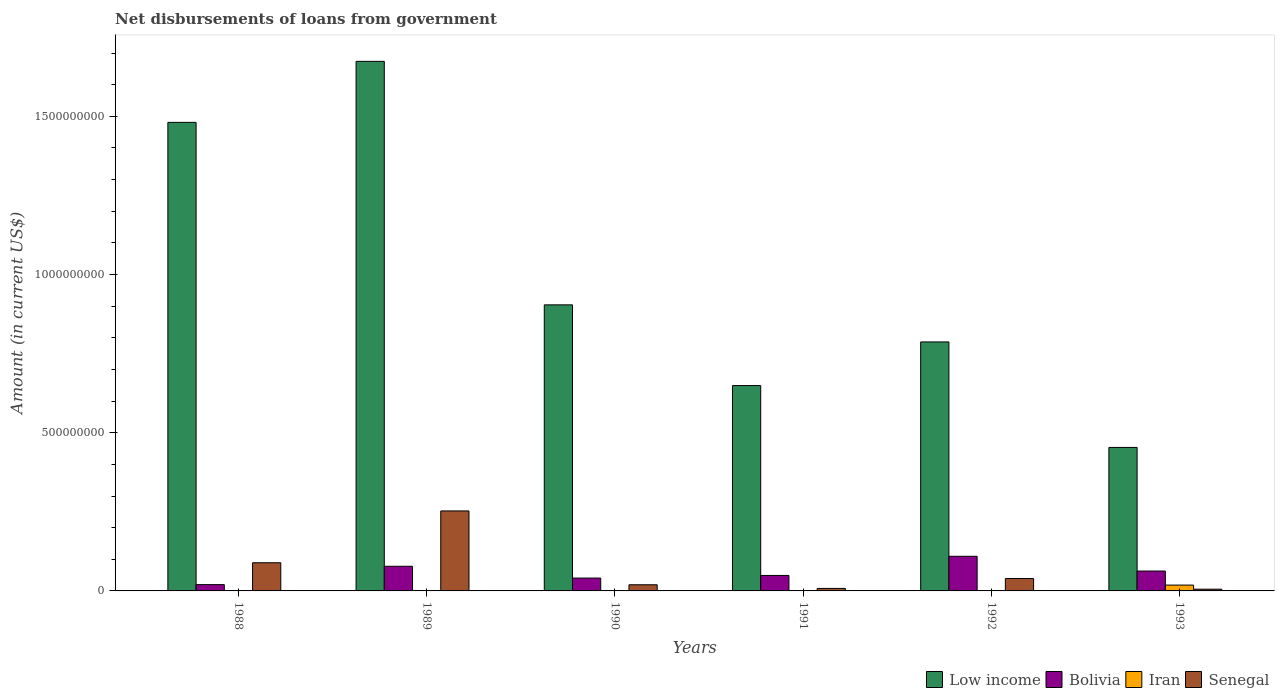How many different coloured bars are there?
Your answer should be compact. 4. How many bars are there on the 1st tick from the left?
Your answer should be compact. 3. How many bars are there on the 4th tick from the right?
Offer a very short reply. 3. What is the label of the 6th group of bars from the left?
Offer a terse response. 1993. In how many cases, is the number of bars for a given year not equal to the number of legend labels?
Make the answer very short. 5. What is the amount of loan disbursed from government in Bolivia in 1989?
Your response must be concise. 7.79e+07. Across all years, what is the maximum amount of loan disbursed from government in Low income?
Give a very brief answer. 1.67e+09. Across all years, what is the minimum amount of loan disbursed from government in Iran?
Offer a terse response. 0. What is the total amount of loan disbursed from government in Iran in the graph?
Your response must be concise. 1.85e+07. What is the difference between the amount of loan disbursed from government in Bolivia in 1991 and that in 1993?
Make the answer very short. -1.39e+07. What is the difference between the amount of loan disbursed from government in Low income in 1992 and the amount of loan disbursed from government in Bolivia in 1989?
Your response must be concise. 7.09e+08. What is the average amount of loan disbursed from government in Iran per year?
Ensure brevity in your answer.  3.08e+06. In the year 1989, what is the difference between the amount of loan disbursed from government in Bolivia and amount of loan disbursed from government in Low income?
Provide a short and direct response. -1.60e+09. In how many years, is the amount of loan disbursed from government in Bolivia greater than 100000000 US$?
Provide a succinct answer. 1. What is the ratio of the amount of loan disbursed from government in Low income in 1989 to that in 1993?
Your answer should be compact. 3.69. Is the difference between the amount of loan disbursed from government in Bolivia in 1989 and 1991 greater than the difference between the amount of loan disbursed from government in Low income in 1989 and 1991?
Keep it short and to the point. No. What is the difference between the highest and the second highest amount of loan disbursed from government in Senegal?
Provide a short and direct response. 1.64e+08. What is the difference between the highest and the lowest amount of loan disbursed from government in Low income?
Give a very brief answer. 1.22e+09. In how many years, is the amount of loan disbursed from government in Senegal greater than the average amount of loan disbursed from government in Senegal taken over all years?
Ensure brevity in your answer.  2. Is the sum of the amount of loan disbursed from government in Bolivia in 1992 and 1993 greater than the maximum amount of loan disbursed from government in Low income across all years?
Your answer should be very brief. No. Is it the case that in every year, the sum of the amount of loan disbursed from government in Bolivia and amount of loan disbursed from government in Low income is greater than the amount of loan disbursed from government in Senegal?
Keep it short and to the point. Yes. How many bars are there?
Ensure brevity in your answer.  19. Does the graph contain grids?
Keep it short and to the point. No. Where does the legend appear in the graph?
Offer a very short reply. Bottom right. How many legend labels are there?
Keep it short and to the point. 4. How are the legend labels stacked?
Keep it short and to the point. Horizontal. What is the title of the graph?
Your answer should be very brief. Net disbursements of loans from government. Does "China" appear as one of the legend labels in the graph?
Make the answer very short. No. What is the label or title of the X-axis?
Make the answer very short. Years. What is the Amount (in current US$) of Low income in 1988?
Give a very brief answer. 1.48e+09. What is the Amount (in current US$) of Bolivia in 1988?
Offer a very short reply. 1.99e+07. What is the Amount (in current US$) in Iran in 1988?
Make the answer very short. 0. What is the Amount (in current US$) of Senegal in 1988?
Provide a short and direct response. 8.91e+07. What is the Amount (in current US$) of Low income in 1989?
Provide a short and direct response. 1.67e+09. What is the Amount (in current US$) in Bolivia in 1989?
Ensure brevity in your answer.  7.79e+07. What is the Amount (in current US$) of Iran in 1989?
Keep it short and to the point. 0. What is the Amount (in current US$) in Senegal in 1989?
Your answer should be compact. 2.53e+08. What is the Amount (in current US$) of Low income in 1990?
Make the answer very short. 9.04e+08. What is the Amount (in current US$) of Bolivia in 1990?
Ensure brevity in your answer.  4.06e+07. What is the Amount (in current US$) of Senegal in 1990?
Your response must be concise. 1.95e+07. What is the Amount (in current US$) of Low income in 1991?
Offer a terse response. 6.49e+08. What is the Amount (in current US$) in Bolivia in 1991?
Your answer should be compact. 4.89e+07. What is the Amount (in current US$) in Iran in 1991?
Ensure brevity in your answer.  0. What is the Amount (in current US$) in Senegal in 1991?
Provide a short and direct response. 7.91e+06. What is the Amount (in current US$) of Low income in 1992?
Your answer should be very brief. 7.87e+08. What is the Amount (in current US$) in Bolivia in 1992?
Your answer should be compact. 1.09e+08. What is the Amount (in current US$) of Iran in 1992?
Make the answer very short. 0. What is the Amount (in current US$) in Senegal in 1992?
Make the answer very short. 3.92e+07. What is the Amount (in current US$) in Low income in 1993?
Your response must be concise. 4.54e+08. What is the Amount (in current US$) of Bolivia in 1993?
Provide a short and direct response. 6.29e+07. What is the Amount (in current US$) in Iran in 1993?
Offer a very short reply. 1.85e+07. What is the Amount (in current US$) of Senegal in 1993?
Make the answer very short. 5.51e+06. Across all years, what is the maximum Amount (in current US$) in Low income?
Provide a succinct answer. 1.67e+09. Across all years, what is the maximum Amount (in current US$) in Bolivia?
Your answer should be very brief. 1.09e+08. Across all years, what is the maximum Amount (in current US$) of Iran?
Offer a terse response. 1.85e+07. Across all years, what is the maximum Amount (in current US$) of Senegal?
Your answer should be compact. 2.53e+08. Across all years, what is the minimum Amount (in current US$) in Low income?
Give a very brief answer. 4.54e+08. Across all years, what is the minimum Amount (in current US$) in Bolivia?
Ensure brevity in your answer.  1.99e+07. Across all years, what is the minimum Amount (in current US$) of Senegal?
Your response must be concise. 5.51e+06. What is the total Amount (in current US$) in Low income in the graph?
Offer a very short reply. 5.95e+09. What is the total Amount (in current US$) in Bolivia in the graph?
Your response must be concise. 3.60e+08. What is the total Amount (in current US$) in Iran in the graph?
Make the answer very short. 1.85e+07. What is the total Amount (in current US$) of Senegal in the graph?
Offer a terse response. 4.14e+08. What is the difference between the Amount (in current US$) of Low income in 1988 and that in 1989?
Give a very brief answer. -1.93e+08. What is the difference between the Amount (in current US$) in Bolivia in 1988 and that in 1989?
Give a very brief answer. -5.79e+07. What is the difference between the Amount (in current US$) of Senegal in 1988 and that in 1989?
Keep it short and to the point. -1.64e+08. What is the difference between the Amount (in current US$) in Low income in 1988 and that in 1990?
Your answer should be compact. 5.77e+08. What is the difference between the Amount (in current US$) of Bolivia in 1988 and that in 1990?
Your answer should be very brief. -2.07e+07. What is the difference between the Amount (in current US$) in Senegal in 1988 and that in 1990?
Provide a short and direct response. 6.96e+07. What is the difference between the Amount (in current US$) in Low income in 1988 and that in 1991?
Make the answer very short. 8.32e+08. What is the difference between the Amount (in current US$) of Bolivia in 1988 and that in 1991?
Your answer should be very brief. -2.90e+07. What is the difference between the Amount (in current US$) of Senegal in 1988 and that in 1991?
Your answer should be very brief. 8.12e+07. What is the difference between the Amount (in current US$) of Low income in 1988 and that in 1992?
Your answer should be compact. 6.94e+08. What is the difference between the Amount (in current US$) in Bolivia in 1988 and that in 1992?
Offer a very short reply. -8.95e+07. What is the difference between the Amount (in current US$) of Senegal in 1988 and that in 1992?
Make the answer very short. 4.99e+07. What is the difference between the Amount (in current US$) in Low income in 1988 and that in 1993?
Offer a terse response. 1.03e+09. What is the difference between the Amount (in current US$) of Bolivia in 1988 and that in 1993?
Provide a succinct answer. -4.29e+07. What is the difference between the Amount (in current US$) of Senegal in 1988 and that in 1993?
Give a very brief answer. 8.36e+07. What is the difference between the Amount (in current US$) in Low income in 1989 and that in 1990?
Offer a terse response. 7.70e+08. What is the difference between the Amount (in current US$) of Bolivia in 1989 and that in 1990?
Your answer should be very brief. 3.73e+07. What is the difference between the Amount (in current US$) of Senegal in 1989 and that in 1990?
Make the answer very short. 2.33e+08. What is the difference between the Amount (in current US$) of Low income in 1989 and that in 1991?
Keep it short and to the point. 1.02e+09. What is the difference between the Amount (in current US$) in Bolivia in 1989 and that in 1991?
Your answer should be very brief. 2.89e+07. What is the difference between the Amount (in current US$) of Senegal in 1989 and that in 1991?
Your answer should be compact. 2.45e+08. What is the difference between the Amount (in current US$) of Low income in 1989 and that in 1992?
Make the answer very short. 8.87e+08. What is the difference between the Amount (in current US$) in Bolivia in 1989 and that in 1992?
Your response must be concise. -3.16e+07. What is the difference between the Amount (in current US$) of Senegal in 1989 and that in 1992?
Offer a very short reply. 2.14e+08. What is the difference between the Amount (in current US$) in Low income in 1989 and that in 1993?
Offer a terse response. 1.22e+09. What is the difference between the Amount (in current US$) of Bolivia in 1989 and that in 1993?
Ensure brevity in your answer.  1.50e+07. What is the difference between the Amount (in current US$) in Senegal in 1989 and that in 1993?
Offer a terse response. 2.47e+08. What is the difference between the Amount (in current US$) in Low income in 1990 and that in 1991?
Your response must be concise. 2.55e+08. What is the difference between the Amount (in current US$) in Bolivia in 1990 and that in 1991?
Make the answer very short. -8.34e+06. What is the difference between the Amount (in current US$) of Senegal in 1990 and that in 1991?
Your answer should be compact. 1.15e+07. What is the difference between the Amount (in current US$) in Low income in 1990 and that in 1992?
Ensure brevity in your answer.  1.17e+08. What is the difference between the Amount (in current US$) of Bolivia in 1990 and that in 1992?
Give a very brief answer. -6.89e+07. What is the difference between the Amount (in current US$) in Senegal in 1990 and that in 1992?
Keep it short and to the point. -1.97e+07. What is the difference between the Amount (in current US$) of Low income in 1990 and that in 1993?
Your answer should be very brief. 4.51e+08. What is the difference between the Amount (in current US$) in Bolivia in 1990 and that in 1993?
Keep it short and to the point. -2.23e+07. What is the difference between the Amount (in current US$) of Senegal in 1990 and that in 1993?
Your answer should be compact. 1.39e+07. What is the difference between the Amount (in current US$) in Low income in 1991 and that in 1992?
Make the answer very short. -1.38e+08. What is the difference between the Amount (in current US$) in Bolivia in 1991 and that in 1992?
Offer a very short reply. -6.05e+07. What is the difference between the Amount (in current US$) of Senegal in 1991 and that in 1992?
Provide a short and direct response. -3.13e+07. What is the difference between the Amount (in current US$) in Low income in 1991 and that in 1993?
Keep it short and to the point. 1.96e+08. What is the difference between the Amount (in current US$) of Bolivia in 1991 and that in 1993?
Your response must be concise. -1.39e+07. What is the difference between the Amount (in current US$) in Senegal in 1991 and that in 1993?
Ensure brevity in your answer.  2.40e+06. What is the difference between the Amount (in current US$) in Low income in 1992 and that in 1993?
Ensure brevity in your answer.  3.33e+08. What is the difference between the Amount (in current US$) of Bolivia in 1992 and that in 1993?
Your response must be concise. 4.66e+07. What is the difference between the Amount (in current US$) of Senegal in 1992 and that in 1993?
Provide a succinct answer. 3.37e+07. What is the difference between the Amount (in current US$) of Low income in 1988 and the Amount (in current US$) of Bolivia in 1989?
Your answer should be very brief. 1.40e+09. What is the difference between the Amount (in current US$) in Low income in 1988 and the Amount (in current US$) in Senegal in 1989?
Ensure brevity in your answer.  1.23e+09. What is the difference between the Amount (in current US$) in Bolivia in 1988 and the Amount (in current US$) in Senegal in 1989?
Make the answer very short. -2.33e+08. What is the difference between the Amount (in current US$) in Low income in 1988 and the Amount (in current US$) in Bolivia in 1990?
Offer a very short reply. 1.44e+09. What is the difference between the Amount (in current US$) in Low income in 1988 and the Amount (in current US$) in Senegal in 1990?
Provide a short and direct response. 1.46e+09. What is the difference between the Amount (in current US$) of Bolivia in 1988 and the Amount (in current US$) of Senegal in 1990?
Your answer should be very brief. 4.83e+05. What is the difference between the Amount (in current US$) in Low income in 1988 and the Amount (in current US$) in Bolivia in 1991?
Your response must be concise. 1.43e+09. What is the difference between the Amount (in current US$) in Low income in 1988 and the Amount (in current US$) in Senegal in 1991?
Ensure brevity in your answer.  1.47e+09. What is the difference between the Amount (in current US$) in Bolivia in 1988 and the Amount (in current US$) in Senegal in 1991?
Offer a very short reply. 1.20e+07. What is the difference between the Amount (in current US$) in Low income in 1988 and the Amount (in current US$) in Bolivia in 1992?
Your answer should be compact. 1.37e+09. What is the difference between the Amount (in current US$) of Low income in 1988 and the Amount (in current US$) of Senegal in 1992?
Keep it short and to the point. 1.44e+09. What is the difference between the Amount (in current US$) in Bolivia in 1988 and the Amount (in current US$) in Senegal in 1992?
Ensure brevity in your answer.  -1.92e+07. What is the difference between the Amount (in current US$) in Low income in 1988 and the Amount (in current US$) in Bolivia in 1993?
Make the answer very short. 1.42e+09. What is the difference between the Amount (in current US$) in Low income in 1988 and the Amount (in current US$) in Iran in 1993?
Your answer should be compact. 1.46e+09. What is the difference between the Amount (in current US$) in Low income in 1988 and the Amount (in current US$) in Senegal in 1993?
Make the answer very short. 1.48e+09. What is the difference between the Amount (in current US$) in Bolivia in 1988 and the Amount (in current US$) in Iran in 1993?
Your response must be concise. 1.48e+06. What is the difference between the Amount (in current US$) in Bolivia in 1988 and the Amount (in current US$) in Senegal in 1993?
Offer a very short reply. 1.44e+07. What is the difference between the Amount (in current US$) in Low income in 1989 and the Amount (in current US$) in Bolivia in 1990?
Provide a short and direct response. 1.63e+09. What is the difference between the Amount (in current US$) of Low income in 1989 and the Amount (in current US$) of Senegal in 1990?
Your answer should be compact. 1.65e+09. What is the difference between the Amount (in current US$) of Bolivia in 1989 and the Amount (in current US$) of Senegal in 1990?
Offer a terse response. 5.84e+07. What is the difference between the Amount (in current US$) in Low income in 1989 and the Amount (in current US$) in Bolivia in 1991?
Your answer should be very brief. 1.62e+09. What is the difference between the Amount (in current US$) of Low income in 1989 and the Amount (in current US$) of Senegal in 1991?
Your answer should be compact. 1.67e+09. What is the difference between the Amount (in current US$) of Bolivia in 1989 and the Amount (in current US$) of Senegal in 1991?
Provide a succinct answer. 7.00e+07. What is the difference between the Amount (in current US$) in Low income in 1989 and the Amount (in current US$) in Bolivia in 1992?
Make the answer very short. 1.56e+09. What is the difference between the Amount (in current US$) of Low income in 1989 and the Amount (in current US$) of Senegal in 1992?
Keep it short and to the point. 1.63e+09. What is the difference between the Amount (in current US$) of Bolivia in 1989 and the Amount (in current US$) of Senegal in 1992?
Offer a very short reply. 3.87e+07. What is the difference between the Amount (in current US$) in Low income in 1989 and the Amount (in current US$) in Bolivia in 1993?
Your answer should be very brief. 1.61e+09. What is the difference between the Amount (in current US$) of Low income in 1989 and the Amount (in current US$) of Iran in 1993?
Offer a very short reply. 1.66e+09. What is the difference between the Amount (in current US$) in Low income in 1989 and the Amount (in current US$) in Senegal in 1993?
Offer a terse response. 1.67e+09. What is the difference between the Amount (in current US$) of Bolivia in 1989 and the Amount (in current US$) of Iran in 1993?
Ensure brevity in your answer.  5.94e+07. What is the difference between the Amount (in current US$) in Bolivia in 1989 and the Amount (in current US$) in Senegal in 1993?
Offer a very short reply. 7.24e+07. What is the difference between the Amount (in current US$) of Low income in 1990 and the Amount (in current US$) of Bolivia in 1991?
Offer a very short reply. 8.55e+08. What is the difference between the Amount (in current US$) of Low income in 1990 and the Amount (in current US$) of Senegal in 1991?
Keep it short and to the point. 8.96e+08. What is the difference between the Amount (in current US$) of Bolivia in 1990 and the Amount (in current US$) of Senegal in 1991?
Your answer should be very brief. 3.27e+07. What is the difference between the Amount (in current US$) of Low income in 1990 and the Amount (in current US$) of Bolivia in 1992?
Provide a short and direct response. 7.95e+08. What is the difference between the Amount (in current US$) in Low income in 1990 and the Amount (in current US$) in Senegal in 1992?
Provide a succinct answer. 8.65e+08. What is the difference between the Amount (in current US$) in Bolivia in 1990 and the Amount (in current US$) in Senegal in 1992?
Ensure brevity in your answer.  1.43e+06. What is the difference between the Amount (in current US$) of Low income in 1990 and the Amount (in current US$) of Bolivia in 1993?
Give a very brief answer. 8.41e+08. What is the difference between the Amount (in current US$) of Low income in 1990 and the Amount (in current US$) of Iran in 1993?
Make the answer very short. 8.86e+08. What is the difference between the Amount (in current US$) in Low income in 1990 and the Amount (in current US$) in Senegal in 1993?
Your response must be concise. 8.99e+08. What is the difference between the Amount (in current US$) in Bolivia in 1990 and the Amount (in current US$) in Iran in 1993?
Ensure brevity in your answer.  2.21e+07. What is the difference between the Amount (in current US$) of Bolivia in 1990 and the Amount (in current US$) of Senegal in 1993?
Provide a short and direct response. 3.51e+07. What is the difference between the Amount (in current US$) of Low income in 1991 and the Amount (in current US$) of Bolivia in 1992?
Ensure brevity in your answer.  5.40e+08. What is the difference between the Amount (in current US$) in Low income in 1991 and the Amount (in current US$) in Senegal in 1992?
Make the answer very short. 6.10e+08. What is the difference between the Amount (in current US$) in Bolivia in 1991 and the Amount (in current US$) in Senegal in 1992?
Provide a succinct answer. 9.76e+06. What is the difference between the Amount (in current US$) in Low income in 1991 and the Amount (in current US$) in Bolivia in 1993?
Offer a very short reply. 5.86e+08. What is the difference between the Amount (in current US$) in Low income in 1991 and the Amount (in current US$) in Iran in 1993?
Make the answer very short. 6.31e+08. What is the difference between the Amount (in current US$) in Low income in 1991 and the Amount (in current US$) in Senegal in 1993?
Your answer should be compact. 6.44e+08. What is the difference between the Amount (in current US$) in Bolivia in 1991 and the Amount (in current US$) in Iran in 1993?
Offer a terse response. 3.05e+07. What is the difference between the Amount (in current US$) of Bolivia in 1991 and the Amount (in current US$) of Senegal in 1993?
Ensure brevity in your answer.  4.34e+07. What is the difference between the Amount (in current US$) of Low income in 1992 and the Amount (in current US$) of Bolivia in 1993?
Offer a very short reply. 7.24e+08. What is the difference between the Amount (in current US$) of Low income in 1992 and the Amount (in current US$) of Iran in 1993?
Your answer should be compact. 7.69e+08. What is the difference between the Amount (in current US$) in Low income in 1992 and the Amount (in current US$) in Senegal in 1993?
Your answer should be compact. 7.81e+08. What is the difference between the Amount (in current US$) of Bolivia in 1992 and the Amount (in current US$) of Iran in 1993?
Your answer should be compact. 9.10e+07. What is the difference between the Amount (in current US$) of Bolivia in 1992 and the Amount (in current US$) of Senegal in 1993?
Your answer should be compact. 1.04e+08. What is the average Amount (in current US$) in Low income per year?
Offer a very short reply. 9.91e+08. What is the average Amount (in current US$) of Bolivia per year?
Your answer should be very brief. 6.00e+07. What is the average Amount (in current US$) of Iran per year?
Ensure brevity in your answer.  3.08e+06. What is the average Amount (in current US$) of Senegal per year?
Keep it short and to the point. 6.90e+07. In the year 1988, what is the difference between the Amount (in current US$) of Low income and Amount (in current US$) of Bolivia?
Your answer should be very brief. 1.46e+09. In the year 1988, what is the difference between the Amount (in current US$) of Low income and Amount (in current US$) of Senegal?
Give a very brief answer. 1.39e+09. In the year 1988, what is the difference between the Amount (in current US$) in Bolivia and Amount (in current US$) in Senegal?
Your response must be concise. -6.91e+07. In the year 1989, what is the difference between the Amount (in current US$) in Low income and Amount (in current US$) in Bolivia?
Offer a terse response. 1.60e+09. In the year 1989, what is the difference between the Amount (in current US$) in Low income and Amount (in current US$) in Senegal?
Your response must be concise. 1.42e+09. In the year 1989, what is the difference between the Amount (in current US$) of Bolivia and Amount (in current US$) of Senegal?
Give a very brief answer. -1.75e+08. In the year 1990, what is the difference between the Amount (in current US$) of Low income and Amount (in current US$) of Bolivia?
Your answer should be compact. 8.64e+08. In the year 1990, what is the difference between the Amount (in current US$) of Low income and Amount (in current US$) of Senegal?
Ensure brevity in your answer.  8.85e+08. In the year 1990, what is the difference between the Amount (in current US$) of Bolivia and Amount (in current US$) of Senegal?
Ensure brevity in your answer.  2.11e+07. In the year 1991, what is the difference between the Amount (in current US$) of Low income and Amount (in current US$) of Bolivia?
Your answer should be very brief. 6.00e+08. In the year 1991, what is the difference between the Amount (in current US$) in Low income and Amount (in current US$) in Senegal?
Offer a terse response. 6.41e+08. In the year 1991, what is the difference between the Amount (in current US$) in Bolivia and Amount (in current US$) in Senegal?
Offer a terse response. 4.10e+07. In the year 1992, what is the difference between the Amount (in current US$) in Low income and Amount (in current US$) in Bolivia?
Your response must be concise. 6.78e+08. In the year 1992, what is the difference between the Amount (in current US$) in Low income and Amount (in current US$) in Senegal?
Your response must be concise. 7.48e+08. In the year 1992, what is the difference between the Amount (in current US$) in Bolivia and Amount (in current US$) in Senegal?
Make the answer very short. 7.03e+07. In the year 1993, what is the difference between the Amount (in current US$) in Low income and Amount (in current US$) in Bolivia?
Keep it short and to the point. 3.91e+08. In the year 1993, what is the difference between the Amount (in current US$) of Low income and Amount (in current US$) of Iran?
Provide a short and direct response. 4.35e+08. In the year 1993, what is the difference between the Amount (in current US$) in Low income and Amount (in current US$) in Senegal?
Your answer should be compact. 4.48e+08. In the year 1993, what is the difference between the Amount (in current US$) of Bolivia and Amount (in current US$) of Iran?
Your answer should be very brief. 4.44e+07. In the year 1993, what is the difference between the Amount (in current US$) of Bolivia and Amount (in current US$) of Senegal?
Provide a short and direct response. 5.74e+07. In the year 1993, what is the difference between the Amount (in current US$) of Iran and Amount (in current US$) of Senegal?
Give a very brief answer. 1.29e+07. What is the ratio of the Amount (in current US$) of Low income in 1988 to that in 1989?
Offer a very short reply. 0.88. What is the ratio of the Amount (in current US$) in Bolivia in 1988 to that in 1989?
Offer a terse response. 0.26. What is the ratio of the Amount (in current US$) in Senegal in 1988 to that in 1989?
Ensure brevity in your answer.  0.35. What is the ratio of the Amount (in current US$) of Low income in 1988 to that in 1990?
Provide a succinct answer. 1.64. What is the ratio of the Amount (in current US$) in Bolivia in 1988 to that in 1990?
Offer a terse response. 0.49. What is the ratio of the Amount (in current US$) in Senegal in 1988 to that in 1990?
Your answer should be compact. 4.58. What is the ratio of the Amount (in current US$) in Low income in 1988 to that in 1991?
Your answer should be very brief. 2.28. What is the ratio of the Amount (in current US$) in Bolivia in 1988 to that in 1991?
Your answer should be very brief. 0.41. What is the ratio of the Amount (in current US$) in Senegal in 1988 to that in 1991?
Make the answer very short. 11.26. What is the ratio of the Amount (in current US$) of Low income in 1988 to that in 1992?
Provide a succinct answer. 1.88. What is the ratio of the Amount (in current US$) of Bolivia in 1988 to that in 1992?
Your answer should be very brief. 0.18. What is the ratio of the Amount (in current US$) of Senegal in 1988 to that in 1992?
Make the answer very short. 2.27. What is the ratio of the Amount (in current US$) in Low income in 1988 to that in 1993?
Your answer should be very brief. 3.27. What is the ratio of the Amount (in current US$) of Bolivia in 1988 to that in 1993?
Your answer should be compact. 0.32. What is the ratio of the Amount (in current US$) in Senegal in 1988 to that in 1993?
Keep it short and to the point. 16.16. What is the ratio of the Amount (in current US$) in Low income in 1989 to that in 1990?
Your response must be concise. 1.85. What is the ratio of the Amount (in current US$) in Bolivia in 1989 to that in 1990?
Your answer should be very brief. 1.92. What is the ratio of the Amount (in current US$) in Senegal in 1989 to that in 1990?
Offer a very short reply. 13. What is the ratio of the Amount (in current US$) of Low income in 1989 to that in 1991?
Give a very brief answer. 2.58. What is the ratio of the Amount (in current US$) in Bolivia in 1989 to that in 1991?
Keep it short and to the point. 1.59. What is the ratio of the Amount (in current US$) in Senegal in 1989 to that in 1991?
Provide a short and direct response. 31.97. What is the ratio of the Amount (in current US$) of Low income in 1989 to that in 1992?
Your answer should be compact. 2.13. What is the ratio of the Amount (in current US$) in Bolivia in 1989 to that in 1992?
Give a very brief answer. 0.71. What is the ratio of the Amount (in current US$) of Senegal in 1989 to that in 1992?
Provide a succinct answer. 6.45. What is the ratio of the Amount (in current US$) of Low income in 1989 to that in 1993?
Your response must be concise. 3.69. What is the ratio of the Amount (in current US$) of Bolivia in 1989 to that in 1993?
Offer a very short reply. 1.24. What is the ratio of the Amount (in current US$) of Senegal in 1989 to that in 1993?
Your answer should be compact. 45.86. What is the ratio of the Amount (in current US$) in Low income in 1990 to that in 1991?
Offer a terse response. 1.39. What is the ratio of the Amount (in current US$) of Bolivia in 1990 to that in 1991?
Your answer should be compact. 0.83. What is the ratio of the Amount (in current US$) of Senegal in 1990 to that in 1991?
Offer a very short reply. 2.46. What is the ratio of the Amount (in current US$) of Low income in 1990 to that in 1992?
Offer a very short reply. 1.15. What is the ratio of the Amount (in current US$) of Bolivia in 1990 to that in 1992?
Provide a succinct answer. 0.37. What is the ratio of the Amount (in current US$) in Senegal in 1990 to that in 1992?
Your response must be concise. 0.5. What is the ratio of the Amount (in current US$) in Low income in 1990 to that in 1993?
Offer a terse response. 1.99. What is the ratio of the Amount (in current US$) of Bolivia in 1990 to that in 1993?
Keep it short and to the point. 0.65. What is the ratio of the Amount (in current US$) in Senegal in 1990 to that in 1993?
Make the answer very short. 3.53. What is the ratio of the Amount (in current US$) of Low income in 1991 to that in 1992?
Your response must be concise. 0.82. What is the ratio of the Amount (in current US$) of Bolivia in 1991 to that in 1992?
Offer a terse response. 0.45. What is the ratio of the Amount (in current US$) of Senegal in 1991 to that in 1992?
Your answer should be very brief. 0.2. What is the ratio of the Amount (in current US$) of Low income in 1991 to that in 1993?
Make the answer very short. 1.43. What is the ratio of the Amount (in current US$) of Bolivia in 1991 to that in 1993?
Keep it short and to the point. 0.78. What is the ratio of the Amount (in current US$) of Senegal in 1991 to that in 1993?
Provide a succinct answer. 1.43. What is the ratio of the Amount (in current US$) in Low income in 1992 to that in 1993?
Ensure brevity in your answer.  1.74. What is the ratio of the Amount (in current US$) of Bolivia in 1992 to that in 1993?
Your answer should be compact. 1.74. What is the ratio of the Amount (in current US$) in Senegal in 1992 to that in 1993?
Offer a terse response. 7.11. What is the difference between the highest and the second highest Amount (in current US$) in Low income?
Give a very brief answer. 1.93e+08. What is the difference between the highest and the second highest Amount (in current US$) of Bolivia?
Provide a succinct answer. 3.16e+07. What is the difference between the highest and the second highest Amount (in current US$) of Senegal?
Keep it short and to the point. 1.64e+08. What is the difference between the highest and the lowest Amount (in current US$) of Low income?
Offer a terse response. 1.22e+09. What is the difference between the highest and the lowest Amount (in current US$) in Bolivia?
Provide a short and direct response. 8.95e+07. What is the difference between the highest and the lowest Amount (in current US$) of Iran?
Offer a very short reply. 1.85e+07. What is the difference between the highest and the lowest Amount (in current US$) of Senegal?
Make the answer very short. 2.47e+08. 